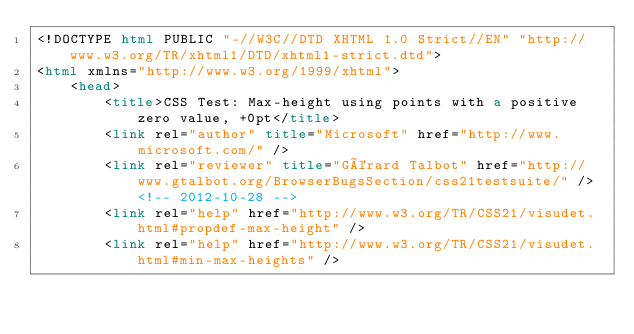Convert code to text. <code><loc_0><loc_0><loc_500><loc_500><_HTML_><!DOCTYPE html PUBLIC "-//W3C//DTD XHTML 1.0 Strict//EN" "http://www.w3.org/TR/xhtml1/DTD/xhtml1-strict.dtd">
<html xmlns="http://www.w3.org/1999/xhtml">
    <head>
        <title>CSS Test: Max-height using points with a positive zero value, +0pt</title>
        <link rel="author" title="Microsoft" href="http://www.microsoft.com/" />
        <link rel="reviewer" title="Gérard Talbot" href="http://www.gtalbot.org/BrowserBugsSection/css21testsuite/" /> <!-- 2012-10-28 -->
        <link rel="help" href="http://www.w3.org/TR/CSS21/visudet.html#propdef-max-height" />
        <link rel="help" href="http://www.w3.org/TR/CSS21/visudet.html#min-max-heights" /></code> 